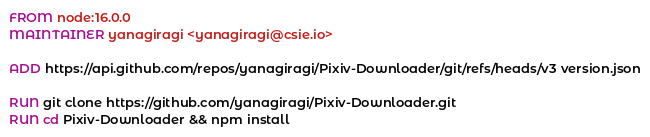<code> <loc_0><loc_0><loc_500><loc_500><_Dockerfile_>FROM node:16.0.0
MAINTAINER yanagiragi <yanagiragi@csie.io>

ADD https://api.github.com/repos/yanagiragi/Pixiv-Downloader/git/refs/heads/v3 version.json

RUN git clone https://github.com/yanagiragi/Pixiv-Downloader.git
RUN cd Pixiv-Downloader && npm install
</code> 